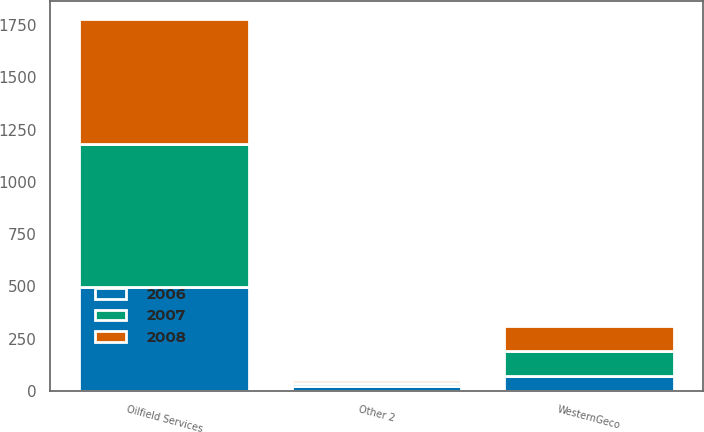<chart> <loc_0><loc_0><loc_500><loc_500><stacked_bar_chart><ecel><fcel>Oilfield Services<fcel>WesternGeco<fcel>Other 2<nl><fcel>2007<fcel>686<fcel>118<fcel>15<nl><fcel>2008<fcel>595<fcel>120<fcel>13<nl><fcel>2006<fcel>496<fcel>73<fcel>23<nl></chart> 